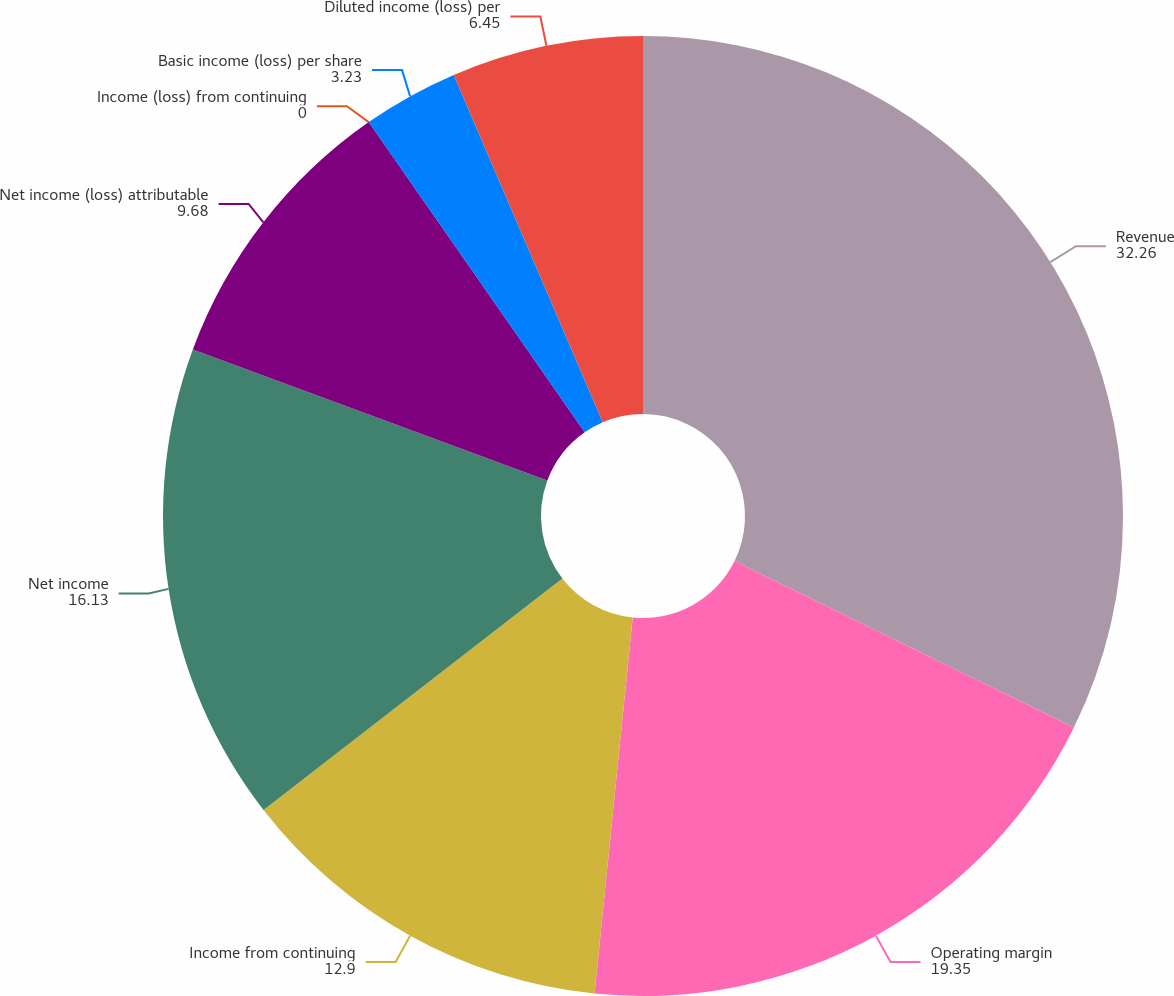Convert chart. <chart><loc_0><loc_0><loc_500><loc_500><pie_chart><fcel>Revenue<fcel>Operating margin<fcel>Income from continuing<fcel>Net income<fcel>Net income (loss) attributable<fcel>Income (loss) from continuing<fcel>Basic income (loss) per share<fcel>Diluted income (loss) per<nl><fcel>32.26%<fcel>19.35%<fcel>12.9%<fcel>16.13%<fcel>9.68%<fcel>0.0%<fcel>3.23%<fcel>6.45%<nl></chart> 